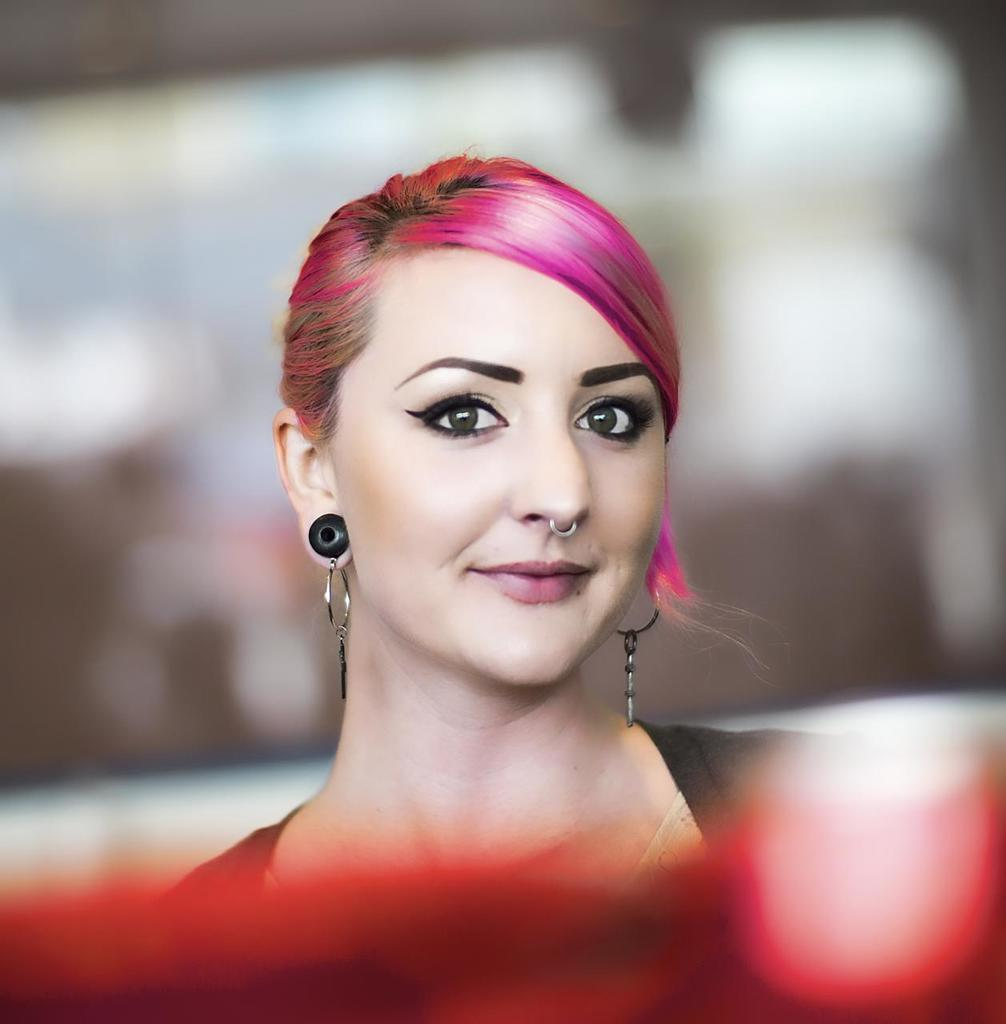What is the main subject of the image? The main subject of the image is a woman. What is the woman doing in the image? The woman is smiling in the image. What is a unique feature of the woman's appearance? The woman has pink hair. What type of accessory is the woman wearing in the image? The woman is wearing black earrings. What type of hand gesture is the woman making in the image? There is no hand gesture visible in the image; the woman is simply smiling. What sense is the woman using to interact with the viewer in the image? The image does not depict the woman interacting with the viewer using any of the five senses. 